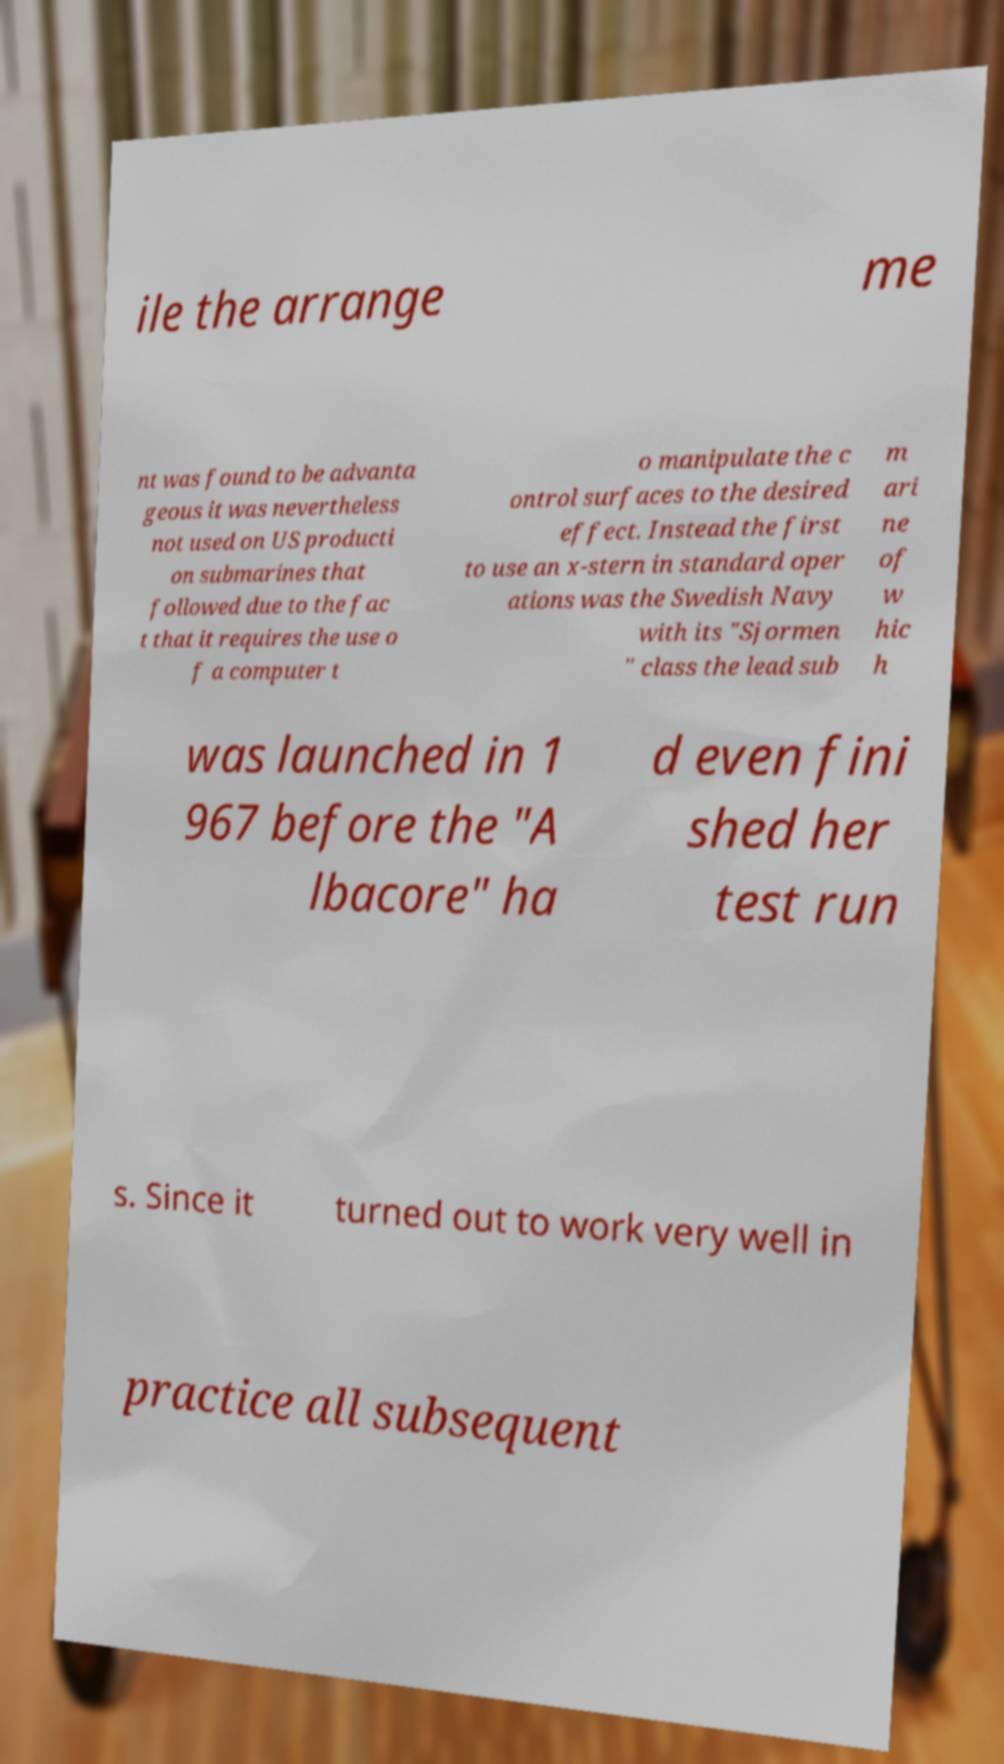Could you extract and type out the text from this image? ile the arrange me nt was found to be advanta geous it was nevertheless not used on US producti on submarines that followed due to the fac t that it requires the use o f a computer t o manipulate the c ontrol surfaces to the desired effect. Instead the first to use an x-stern in standard oper ations was the Swedish Navy with its "Sjormen " class the lead sub m ari ne of w hic h was launched in 1 967 before the "A lbacore" ha d even fini shed her test run s. Since it turned out to work very well in practice all subsequent 